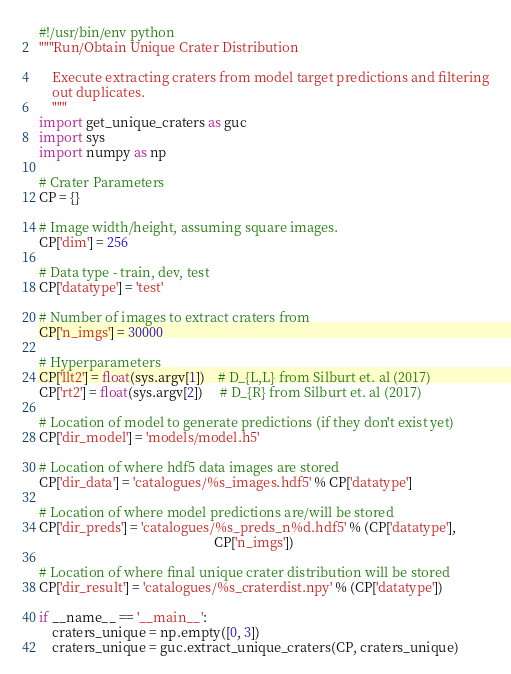Convert code to text. <code><loc_0><loc_0><loc_500><loc_500><_Python_>#!/usr/bin/env python
"""Run/Obtain Unique Crater Distribution

    Execute extracting craters from model target predictions and filtering
    out duplicates.
    """
import get_unique_craters as guc
import sys
import numpy as np

# Crater Parameters
CP = {}

# Image width/height, assuming square images.
CP['dim'] = 256

# Data type - train, dev, test
CP['datatype'] = 'test'

# Number of images to extract craters from
CP['n_imgs'] = 30000

# Hyperparameters
CP['llt2'] = float(sys.argv[1])    # D_{L,L} from Silburt et. al (2017)
CP['rt2'] = float(sys.argv[2])     # D_{R} from Silburt et. al (2017)

# Location of model to generate predictions (if they don't exist yet)
CP['dir_model'] = 'models/model.h5'

# Location of where hdf5 data images are stored
CP['dir_data'] = 'catalogues/%s_images.hdf5' % CP['datatype']

# Location of where model predictions are/will be stored
CP['dir_preds'] = 'catalogues/%s_preds_n%d.hdf5' % (CP['datatype'],
                                                    CP['n_imgs'])

# Location of where final unique crater distribution will be stored
CP['dir_result'] = 'catalogues/%s_craterdist.npy' % (CP['datatype'])

if __name__ == '__main__':
    craters_unique = np.empty([0, 3])
    craters_unique = guc.extract_unique_craters(CP, craters_unique)
</code> 